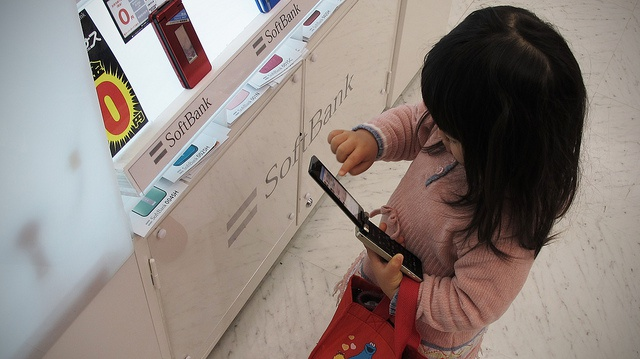Describe the objects in this image and their specific colors. I can see people in gray, black, brown, and maroon tones, handbag in gray, maroon, black, and blue tones, cell phone in gray, black, and darkgray tones, cell phone in gray, maroon, black, and brown tones, and cell phone in gray, navy, blue, and lightgray tones in this image. 